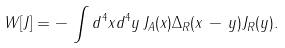Convert formula to latex. <formula><loc_0><loc_0><loc_500><loc_500>W [ J ] = - \, \int d ^ { 4 } x d ^ { 4 } y \, J _ { A } ( x ) \Delta _ { R } ( x \, - \, y ) J _ { R } ( y ) .</formula> 